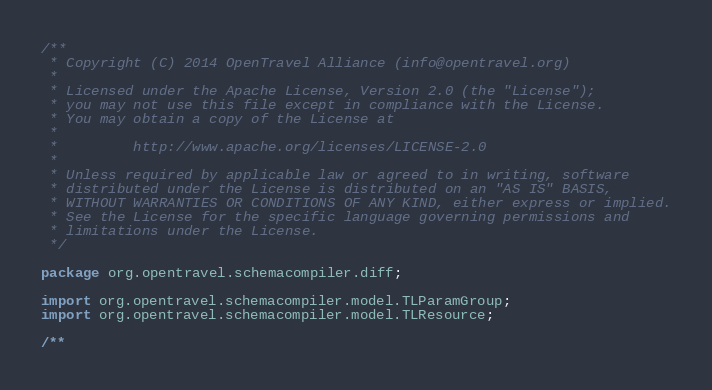<code> <loc_0><loc_0><loc_500><loc_500><_Java_>/**
 * Copyright (C) 2014 OpenTravel Alliance (info@opentravel.org)
 *
 * Licensed under the Apache License, Version 2.0 (the "License");
 * you may not use this file except in compliance with the License.
 * You may obtain a copy of the License at
 *
 *         http://www.apache.org/licenses/LICENSE-2.0
 *
 * Unless required by applicable law or agreed to in writing, software
 * distributed under the License is distributed on an "AS IS" BASIS,
 * WITHOUT WARRANTIES OR CONDITIONS OF ANY KIND, either express or implied.
 * See the License for the specific language governing permissions and
 * limitations under the License.
 */

package org.opentravel.schemacompiler.diff;

import org.opentravel.schemacompiler.model.TLParamGroup;
import org.opentravel.schemacompiler.model.TLResource;

/**</code> 